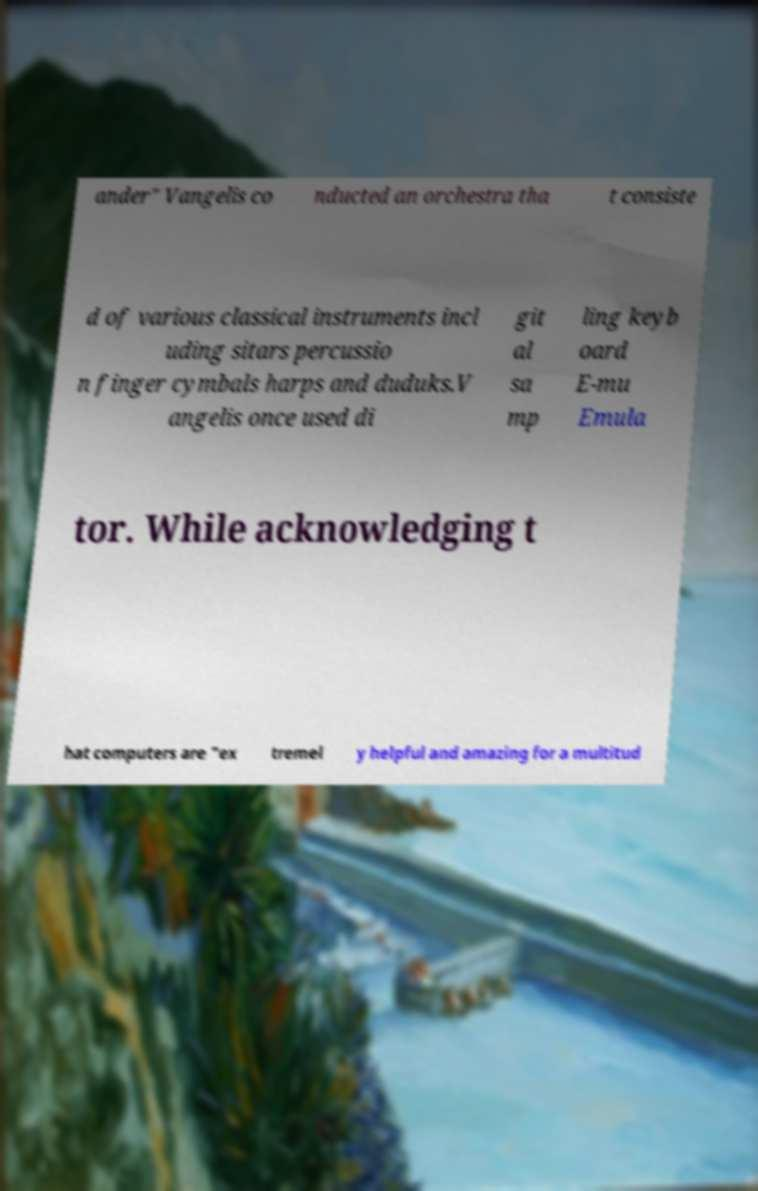Can you accurately transcribe the text from the provided image for me? ander" Vangelis co nducted an orchestra tha t consiste d of various classical instruments incl uding sitars percussio n finger cymbals harps and duduks.V angelis once used di git al sa mp ling keyb oard E-mu Emula tor. While acknowledging t hat computers are "ex tremel y helpful and amazing for a multitud 